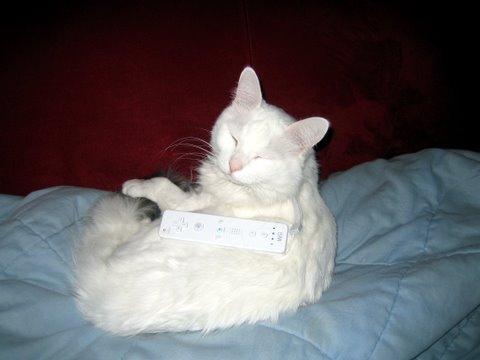<image>What color is the couch? I am not sure. The color of the couch can be seen either 'gray', 'red', 'white' or 'blue'. What color is the couch? The couch in the image is either gray, white, red or blue. 